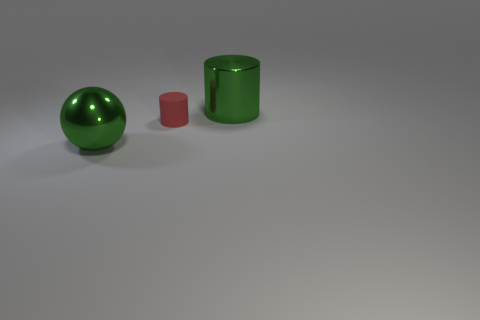Are there any big metallic spheres of the same color as the big cylinder?
Your answer should be very brief. Yes. There is a thing that is the same color as the large metal cylinder; what material is it?
Give a very brief answer. Metal. Does the big metal sphere have the same color as the big cylinder?
Your answer should be very brief. Yes. Is there any other thing that is made of the same material as the tiny object?
Keep it short and to the point. No. Is the number of spheres that are left of the green metallic ball less than the number of tiny blue rubber cylinders?
Give a very brief answer. No. How many metal balls have the same size as the green cylinder?
Offer a very short reply. 1. What shape is the thing that is the same color as the sphere?
Provide a short and direct response. Cylinder. Is the color of the large cylinder that is behind the small red thing the same as the metallic thing that is left of the small rubber object?
Your response must be concise. Yes. How many small rubber things are on the left side of the metallic sphere?
Your answer should be very brief. 0. Is there a big metallic object that has the same shape as the tiny red matte thing?
Provide a short and direct response. Yes. 